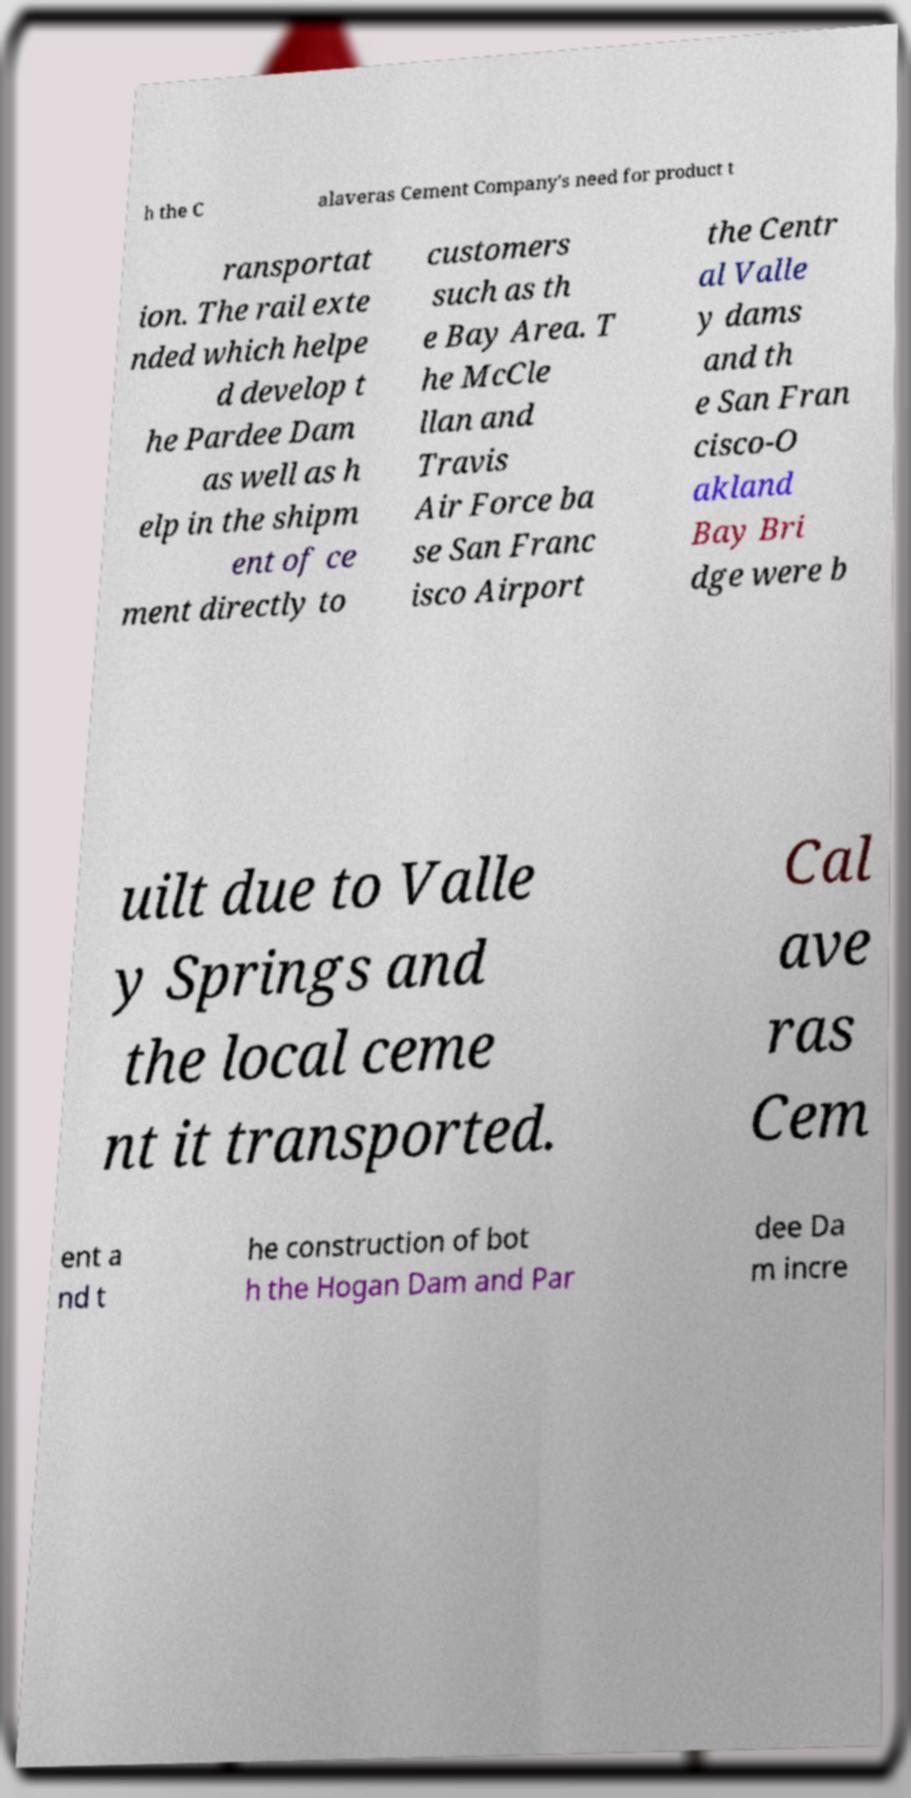Can you read and provide the text displayed in the image?This photo seems to have some interesting text. Can you extract and type it out for me? h the C alaveras Cement Company's need for product t ransportat ion. The rail exte nded which helpe d develop t he Pardee Dam as well as h elp in the shipm ent of ce ment directly to customers such as th e Bay Area. T he McCle llan and Travis Air Force ba se San Franc isco Airport the Centr al Valle y dams and th e San Fran cisco-O akland Bay Bri dge were b uilt due to Valle y Springs and the local ceme nt it transported. Cal ave ras Cem ent a nd t he construction of bot h the Hogan Dam and Par dee Da m incre 